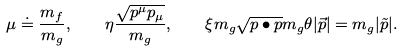<formula> <loc_0><loc_0><loc_500><loc_500>\mu \doteq \frac { m _ { f } } { m _ { g } } , \quad \eta \frac { \sqrt { p ^ { \mu } p _ { \mu } } } { m _ { g } } , \quad \xi m _ { g } \sqrt { p \bullet p } m _ { g } \theta | \vec { p } | = m _ { g } | \tilde { p } | .</formula> 